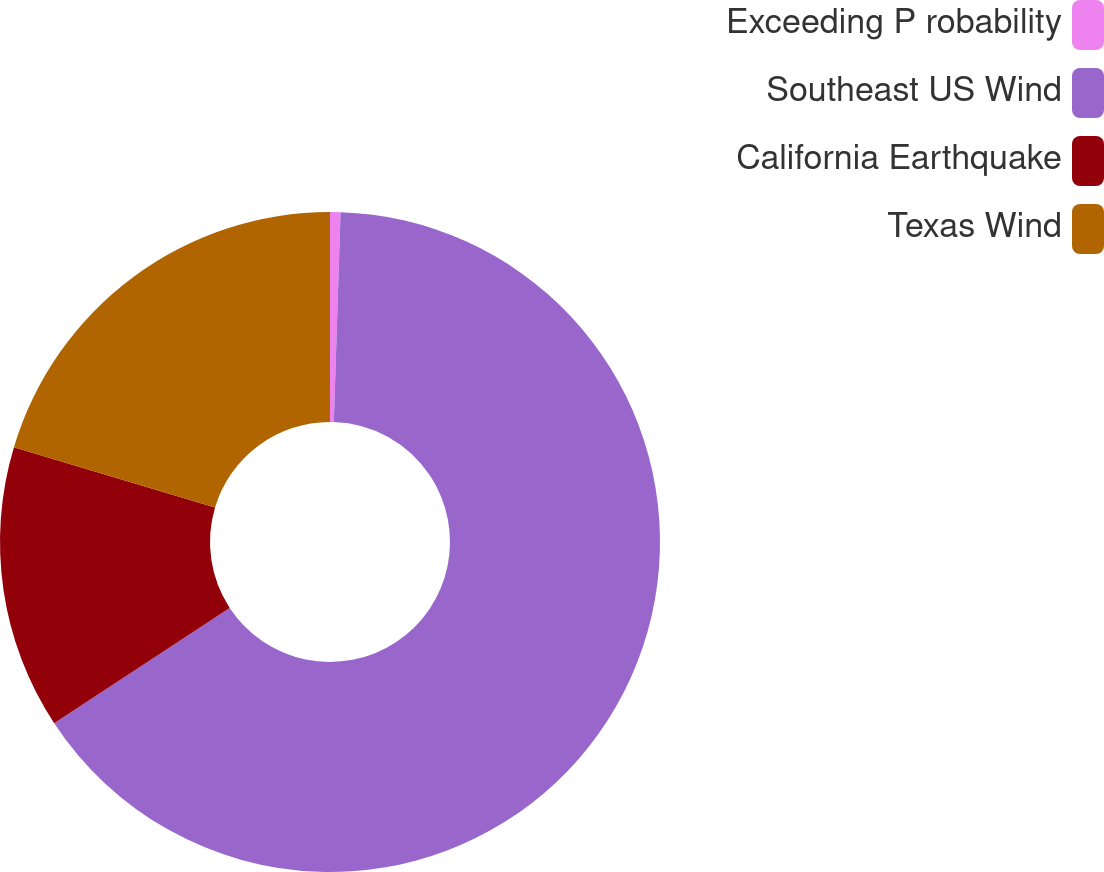Convert chart to OTSL. <chart><loc_0><loc_0><loc_500><loc_500><pie_chart><fcel>Exceeding P robability<fcel>Southeast US Wind<fcel>California Earthquake<fcel>Texas Wind<nl><fcel>0.51%<fcel>65.24%<fcel>13.89%<fcel>20.36%<nl></chart> 